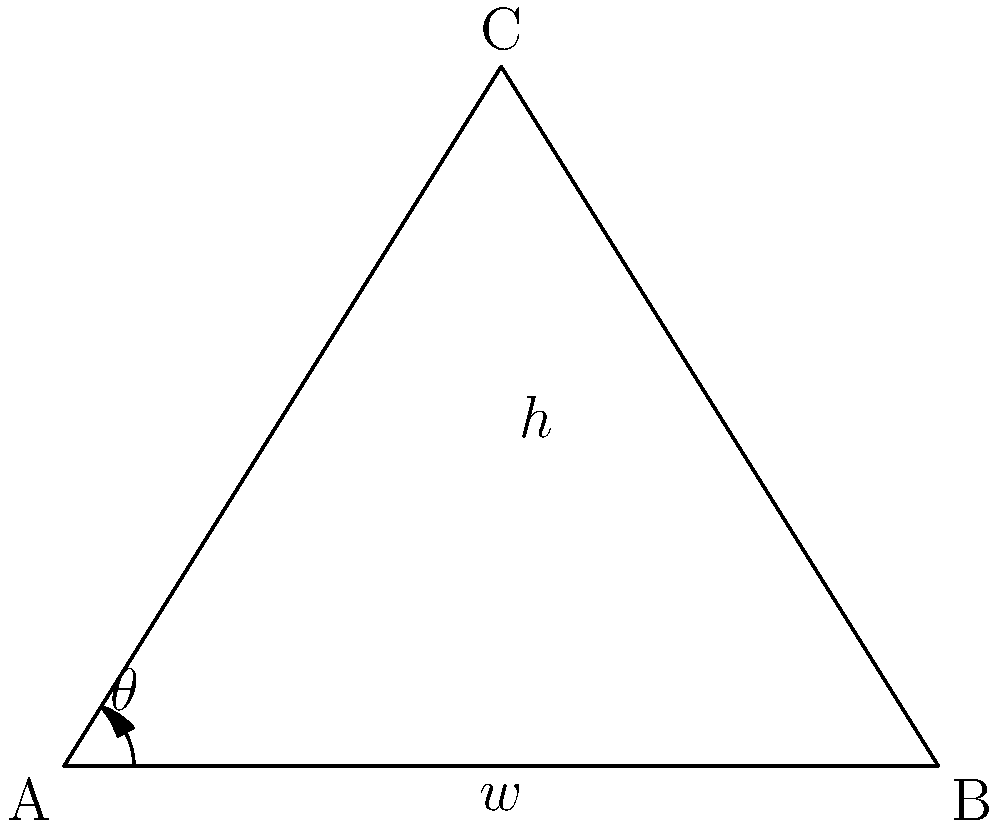In designing a greenhouse roof for optimal sunlight exposure for organic crops, you need to determine the angle of inclination. Given that the width of the greenhouse base is 10 meters and the height of the roof peak is 8 meters, what is the angle of inclination $\theta$ (in degrees) of the roof? To find the angle of inclination $\theta$, we can use trigonometry in the right triangle formed by half of the greenhouse roof:

1. Identify the known dimensions:
   - Width of the base: $w = 10$ meters
   - Height of the roof peak: $h = 8$ meters

2. We need to use half of the width for our calculations:
   $\frac{w}{2} = 5$ meters

3. Now we have a right triangle with:
   - Adjacent side (half-width): 5 meters
   - Opposite side (height): 8 meters

4. We can use the tangent function to find the angle:
   $$\tan(\theta) = \frac{\text{opposite}}{\text{adjacent}} = \frac{8}{5}$$

5. To solve for $\theta$, we take the inverse tangent (arctangent):
   $$\theta = \tan^{-1}\left(\frac{8}{5}\right)$$

6. Using a calculator or computational tool:
   $$\theta \approx 58.0^\circ$$

Therefore, the angle of inclination of the greenhouse roof is approximately 58.0 degrees.
Answer: $58.0^\circ$ 